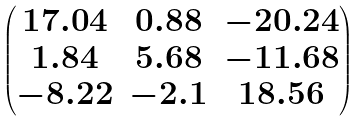<formula> <loc_0><loc_0><loc_500><loc_500>\begin{pmatrix} 1 7 . 0 4 & 0 . 8 8 & - 2 0 . 2 4 \\ 1 . 8 4 & 5 . 6 8 & - 1 1 . 6 8 \\ - 8 . 2 2 & - 2 . 1 & 1 8 . 5 6 \\ \end{pmatrix}</formula> 